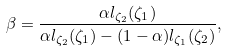<formula> <loc_0><loc_0><loc_500><loc_500>\beta = \frac { \alpha l _ { \zeta _ { 2 } } ( \zeta _ { 1 } ) } { \alpha l _ { \zeta _ { 2 } } ( \zeta _ { 1 } ) - ( 1 - \alpha ) l _ { \zeta _ { 1 } } ( \zeta _ { 2 } ) } ,</formula> 